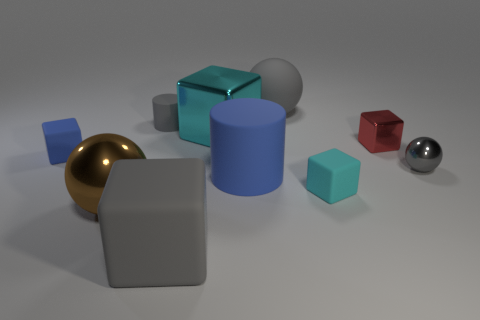Subtract all red cubes. How many cubes are left? 4 Subtract all red blocks. How many blocks are left? 4 Subtract all balls. How many objects are left? 7 Subtract 1 cylinders. How many cylinders are left? 1 Subtract all purple balls. Subtract all gray cylinders. How many balls are left? 3 Subtract all red cubes. How many blue cylinders are left? 1 Subtract all large rubber cylinders. Subtract all cyan matte objects. How many objects are left? 8 Add 1 tiny gray cylinders. How many tiny gray cylinders are left? 2 Add 7 big gray objects. How many big gray objects exist? 9 Subtract 0 green blocks. How many objects are left? 10 